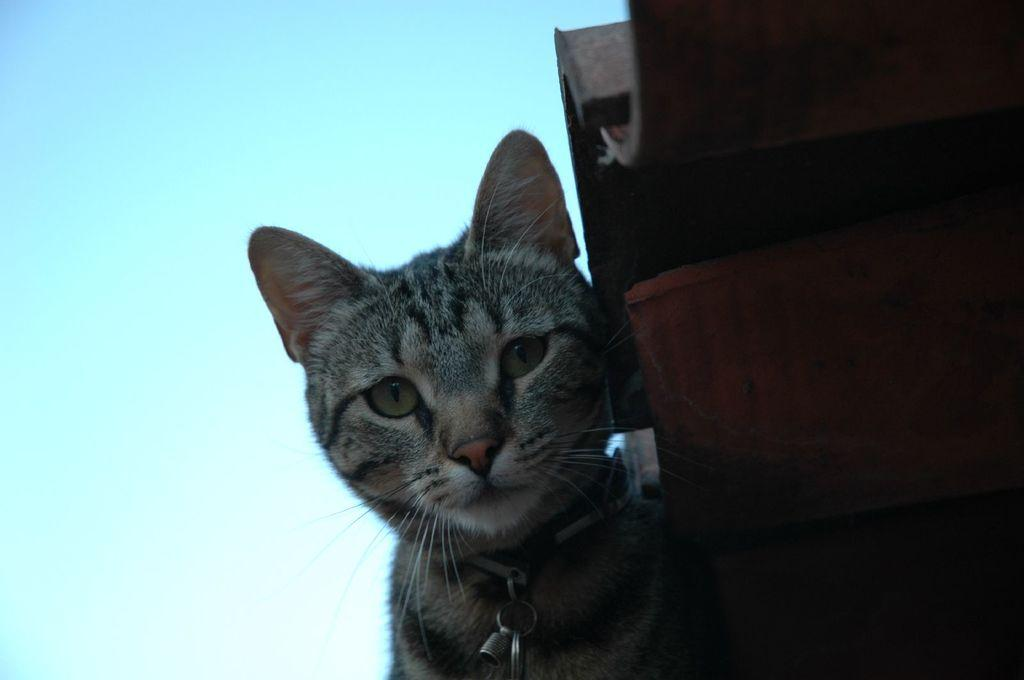What type of animal is present in the image? There is a cat in the image. What object is related to the cat in the image? There is a cat belt in the image. What is the color of the sky in the image? The sky is pale blue in the image. What type of pie is the cat ordering in the image? There is no pie present in the image, nor is the cat ordering anything. 